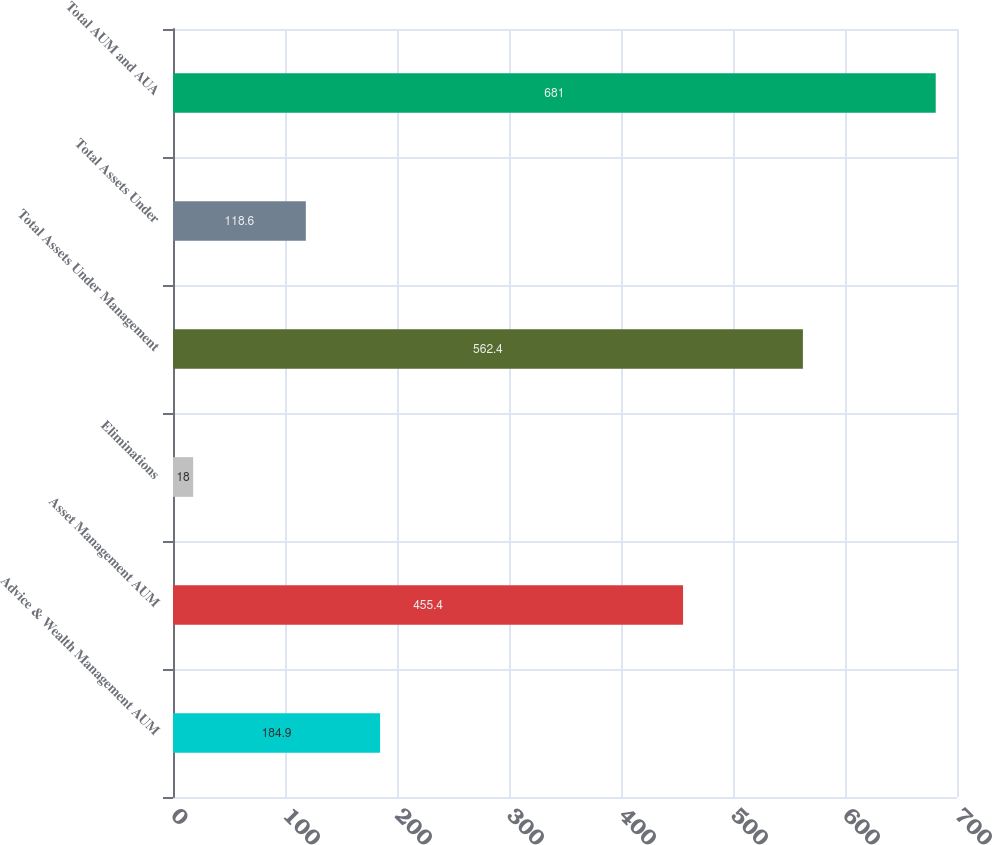Convert chart. <chart><loc_0><loc_0><loc_500><loc_500><bar_chart><fcel>Advice & Wealth Management AUM<fcel>Asset Management AUM<fcel>Eliminations<fcel>Total Assets Under Management<fcel>Total Assets Under<fcel>Total AUM and AUA<nl><fcel>184.9<fcel>455.4<fcel>18<fcel>562.4<fcel>118.6<fcel>681<nl></chart> 